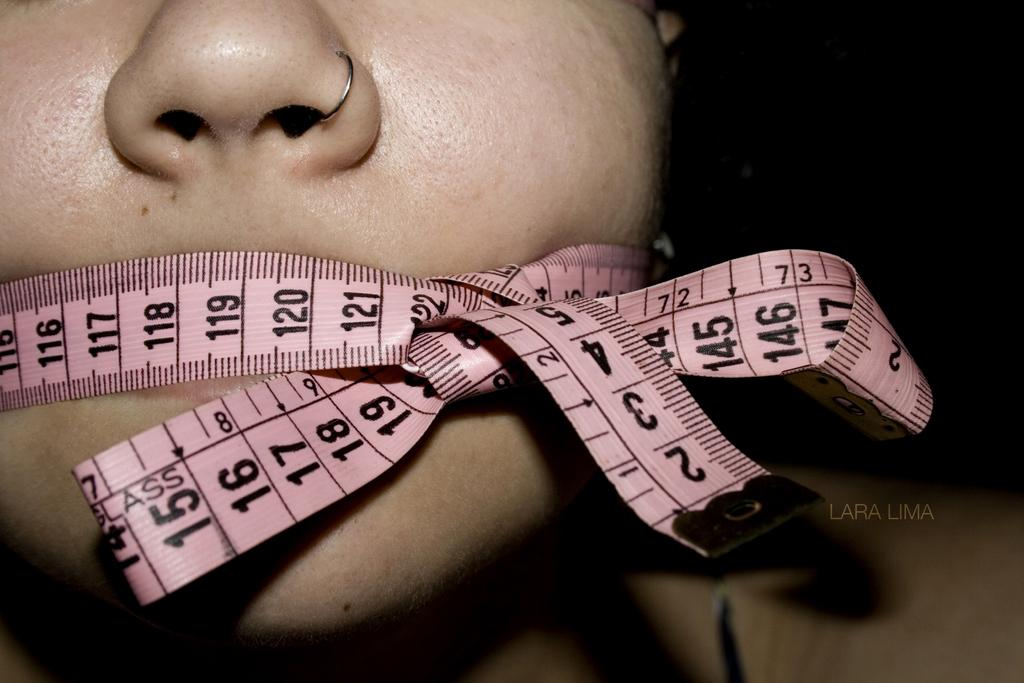Who is the main subject in the image? There is a woman in the image. What is a notable feature of the woman's appearance? The woman's mouth is taped. What type of tent can be seen in the background of the image? There is no tent present in the image; it only features a woman with her mouth taped. 